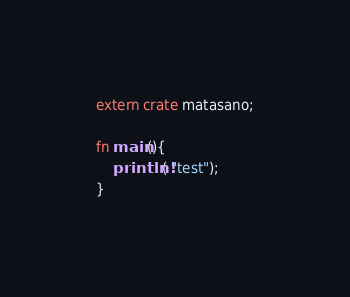<code> <loc_0><loc_0><loc_500><loc_500><_Rust_>extern crate matasano;

fn main(){
	println!( "test");
}
</code> 